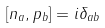Convert formula to latex. <formula><loc_0><loc_0><loc_500><loc_500>[ n _ { a } , p _ { b } ] = i \delta _ { a b }</formula> 